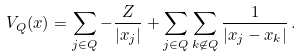<formula> <loc_0><loc_0><loc_500><loc_500>V _ { Q } ( { x } ) = \sum _ { j \in Q } - \frac { Z } { | x _ { j } | } + \sum _ { j \in Q } \sum _ { k \not \in Q } \frac { 1 } { | x _ { j } - x _ { k } | } \, .</formula> 